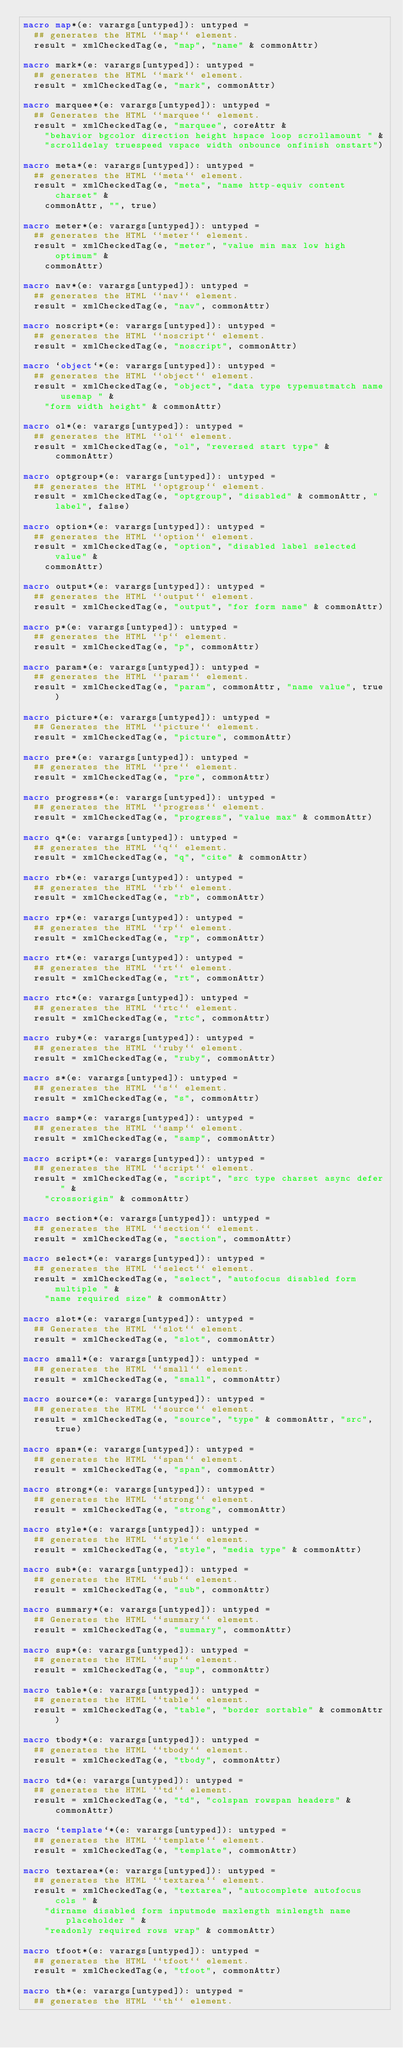Convert code to text. <code><loc_0><loc_0><loc_500><loc_500><_Nim_>macro map*(e: varargs[untyped]): untyped =
  ## generates the HTML ``map`` element.
  result = xmlCheckedTag(e, "map", "name" & commonAttr)

macro mark*(e: varargs[untyped]): untyped =
  ## generates the HTML ``mark`` element.
  result = xmlCheckedTag(e, "mark", commonAttr)

macro marquee*(e: varargs[untyped]): untyped =
  ## Generates the HTML ``marquee`` element.
  result = xmlCheckedTag(e, "marquee", coreAttr &
    "behavior bgcolor direction height hspace loop scrollamount " &
    "scrolldelay truespeed vspace width onbounce onfinish onstart")

macro meta*(e: varargs[untyped]): untyped =
  ## generates the HTML ``meta`` element.
  result = xmlCheckedTag(e, "meta", "name http-equiv content charset" &
    commonAttr, "", true)

macro meter*(e: varargs[untyped]): untyped =
  ## generates the HTML ``meter`` element.
  result = xmlCheckedTag(e, "meter", "value min max low high optimum" &
    commonAttr)

macro nav*(e: varargs[untyped]): untyped =
  ## generates the HTML ``nav`` element.
  result = xmlCheckedTag(e, "nav", commonAttr)

macro noscript*(e: varargs[untyped]): untyped =
  ## generates the HTML ``noscript`` element.
  result = xmlCheckedTag(e, "noscript", commonAttr)

macro `object`*(e: varargs[untyped]): untyped =
  ## generates the HTML ``object`` element.
  result = xmlCheckedTag(e, "object", "data type typemustmatch name usemap " &
    "form width height" & commonAttr)

macro ol*(e: varargs[untyped]): untyped =
  ## generates the HTML ``ol`` element.
  result = xmlCheckedTag(e, "ol", "reversed start type" & commonAttr)

macro optgroup*(e: varargs[untyped]): untyped =
  ## generates the HTML ``optgroup`` element.
  result = xmlCheckedTag(e, "optgroup", "disabled" & commonAttr, "label", false)

macro option*(e: varargs[untyped]): untyped =
  ## generates the HTML ``option`` element.
  result = xmlCheckedTag(e, "option", "disabled label selected value" &
    commonAttr)

macro output*(e: varargs[untyped]): untyped =
  ## generates the HTML ``output`` element.
  result = xmlCheckedTag(e, "output", "for form name" & commonAttr)

macro p*(e: varargs[untyped]): untyped =
  ## generates the HTML ``p`` element.
  result = xmlCheckedTag(e, "p", commonAttr)

macro param*(e: varargs[untyped]): untyped =
  ## generates the HTML ``param`` element.
  result = xmlCheckedTag(e, "param", commonAttr, "name value", true)

macro picture*(e: varargs[untyped]): untyped =
  ## Generates the HTML ``picture`` element.
  result = xmlCheckedTag(e, "picture", commonAttr)

macro pre*(e: varargs[untyped]): untyped =
  ## generates the HTML ``pre`` element.
  result = xmlCheckedTag(e, "pre", commonAttr)

macro progress*(e: varargs[untyped]): untyped =
  ## generates the HTML ``progress`` element.
  result = xmlCheckedTag(e, "progress", "value max" & commonAttr)

macro q*(e: varargs[untyped]): untyped =
  ## generates the HTML ``q`` element.
  result = xmlCheckedTag(e, "q", "cite" & commonAttr)

macro rb*(e: varargs[untyped]): untyped =
  ## generates the HTML ``rb`` element.
  result = xmlCheckedTag(e, "rb", commonAttr)

macro rp*(e: varargs[untyped]): untyped =
  ## generates the HTML ``rp`` element.
  result = xmlCheckedTag(e, "rp", commonAttr)

macro rt*(e: varargs[untyped]): untyped =
  ## generates the HTML ``rt`` element.
  result = xmlCheckedTag(e, "rt", commonAttr)

macro rtc*(e: varargs[untyped]): untyped =
  ## generates the HTML ``rtc`` element.
  result = xmlCheckedTag(e, "rtc", commonAttr)

macro ruby*(e: varargs[untyped]): untyped =
  ## generates the HTML ``ruby`` element.
  result = xmlCheckedTag(e, "ruby", commonAttr)

macro s*(e: varargs[untyped]): untyped =
  ## generates the HTML ``s`` element.
  result = xmlCheckedTag(e, "s", commonAttr)

macro samp*(e: varargs[untyped]): untyped =
  ## generates the HTML ``samp`` element.
  result = xmlCheckedTag(e, "samp", commonAttr)

macro script*(e: varargs[untyped]): untyped =
  ## generates the HTML ``script`` element.
  result = xmlCheckedTag(e, "script", "src type charset async defer " &
    "crossorigin" & commonAttr)

macro section*(e: varargs[untyped]): untyped =
  ## generates the HTML ``section`` element.
  result = xmlCheckedTag(e, "section", commonAttr)

macro select*(e: varargs[untyped]): untyped =
  ## generates the HTML ``select`` element.
  result = xmlCheckedTag(e, "select", "autofocus disabled form multiple " &
    "name required size" & commonAttr)

macro slot*(e: varargs[untyped]): untyped =
  ## Generates the HTML ``slot`` element.
  result = xmlCheckedTag(e, "slot", commonAttr)

macro small*(e: varargs[untyped]): untyped =
  ## generates the HTML ``small`` element.
  result = xmlCheckedTag(e, "small", commonAttr)

macro source*(e: varargs[untyped]): untyped =
  ## generates the HTML ``source`` element.
  result = xmlCheckedTag(e, "source", "type" & commonAttr, "src", true)

macro span*(e: varargs[untyped]): untyped =
  ## generates the HTML ``span`` element.
  result = xmlCheckedTag(e, "span", commonAttr)

macro strong*(e: varargs[untyped]): untyped =
  ## generates the HTML ``strong`` element.
  result = xmlCheckedTag(e, "strong", commonAttr)

macro style*(e: varargs[untyped]): untyped =
  ## generates the HTML ``style`` element.
  result = xmlCheckedTag(e, "style", "media type" & commonAttr)

macro sub*(e: varargs[untyped]): untyped =
  ## generates the HTML ``sub`` element.
  result = xmlCheckedTag(e, "sub", commonAttr)

macro summary*(e: varargs[untyped]): untyped =
  ## Generates the HTML ``summary`` element.
  result = xmlCheckedTag(e, "summary", commonAttr)

macro sup*(e: varargs[untyped]): untyped =
  ## generates the HTML ``sup`` element.
  result = xmlCheckedTag(e, "sup", commonAttr)

macro table*(e: varargs[untyped]): untyped =
  ## generates the HTML ``table`` element.
  result = xmlCheckedTag(e, "table", "border sortable" & commonAttr)

macro tbody*(e: varargs[untyped]): untyped =
  ## generates the HTML ``tbody`` element.
  result = xmlCheckedTag(e, "tbody", commonAttr)

macro td*(e: varargs[untyped]): untyped =
  ## generates the HTML ``td`` element.
  result = xmlCheckedTag(e, "td", "colspan rowspan headers" & commonAttr)

macro `template`*(e: varargs[untyped]): untyped =
  ## generates the HTML ``template`` element.
  result = xmlCheckedTag(e, "template", commonAttr)

macro textarea*(e: varargs[untyped]): untyped =
  ## generates the HTML ``textarea`` element.
  result = xmlCheckedTag(e, "textarea", "autocomplete autofocus cols " &
    "dirname disabled form inputmode maxlength minlength name placeholder " &
    "readonly required rows wrap" & commonAttr)

macro tfoot*(e: varargs[untyped]): untyped =
  ## generates the HTML ``tfoot`` element.
  result = xmlCheckedTag(e, "tfoot", commonAttr)

macro th*(e: varargs[untyped]): untyped =
  ## generates the HTML ``th`` element.</code> 